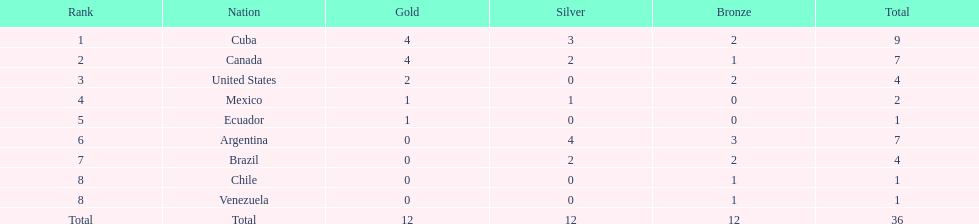What were the participating nations in canoeing during the 2011 pan american games? Cuba, Canada, United States, Mexico, Ecuador, Argentina, Brazil, Chile, Venezuela, Total. Of these, which had an assigned rank? Cuba, Canada, United States, Mexico, Ecuador, Argentina, Brazil, Chile, Venezuela. From these countries, which one secured the most bronze medals? Argentina. 